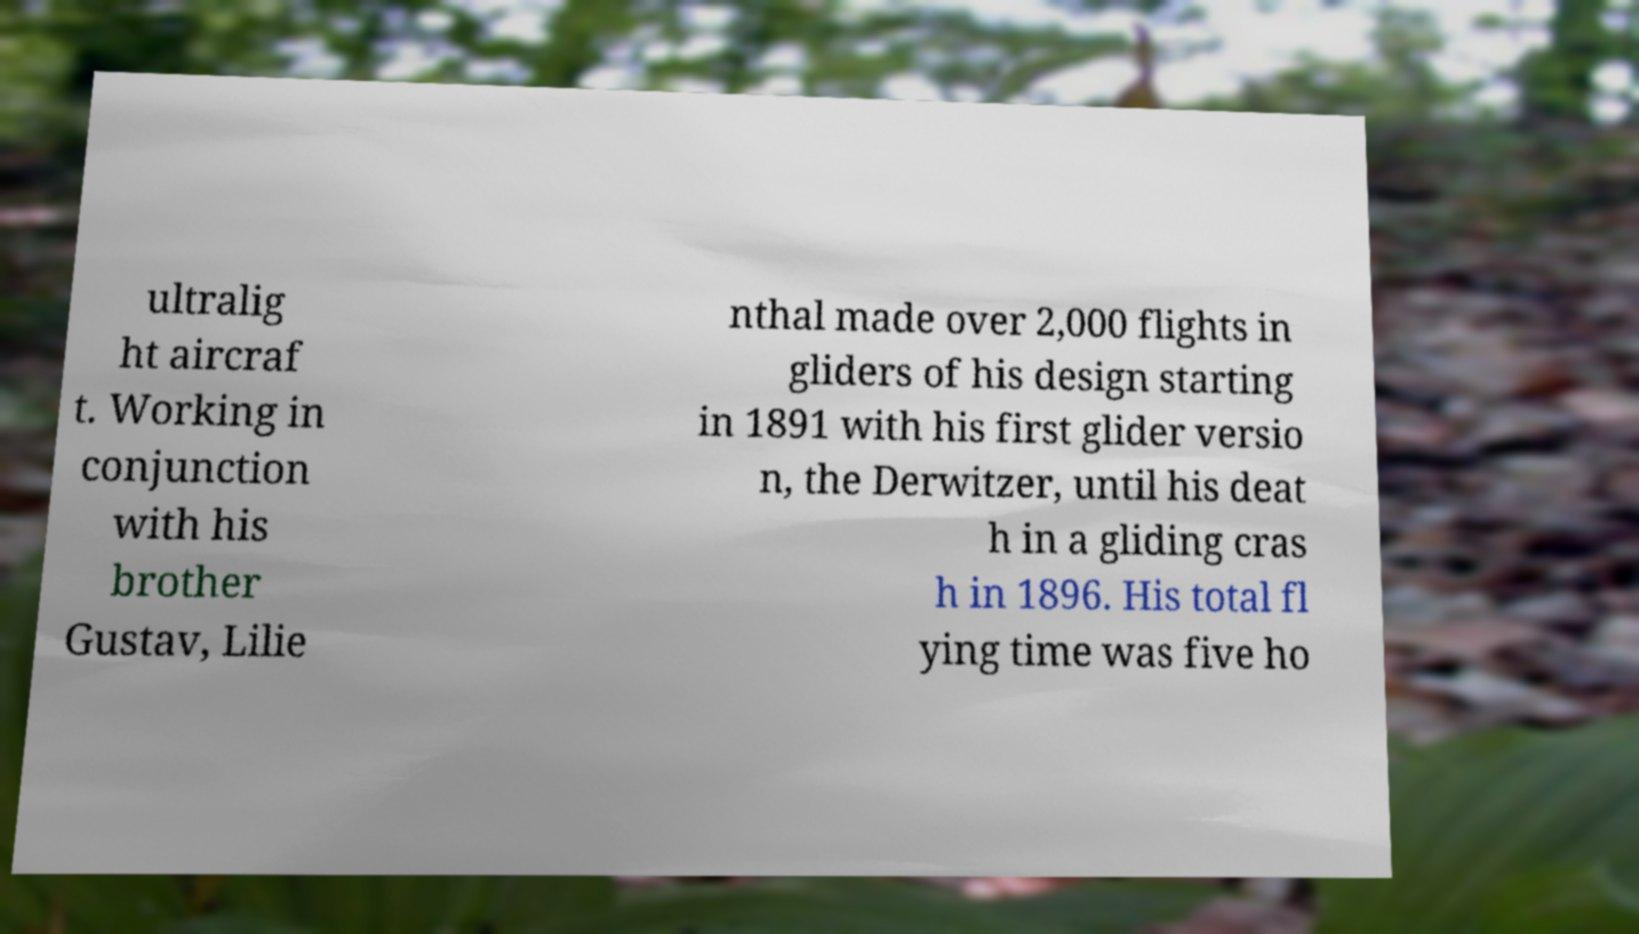Please read and relay the text visible in this image. What does it say? ultralig ht aircraf t. Working in conjunction with his brother Gustav, Lilie nthal made over 2,000 flights in gliders of his design starting in 1891 with his first glider versio n, the Derwitzer, until his deat h in a gliding cras h in 1896. His total fl ying time was five ho 